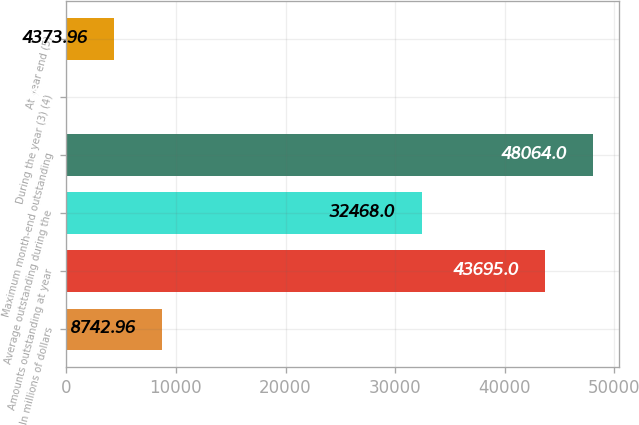<chart> <loc_0><loc_0><loc_500><loc_500><bar_chart><fcel>In millions of dollars<fcel>Amounts outstanding at year<fcel>Average outstanding during the<fcel>Maximum month-end outstanding<fcel>During the year (3) (4)<fcel>At year end (5)<nl><fcel>8742.96<fcel>43695<fcel>32468<fcel>48064<fcel>4.96<fcel>4373.96<nl></chart> 